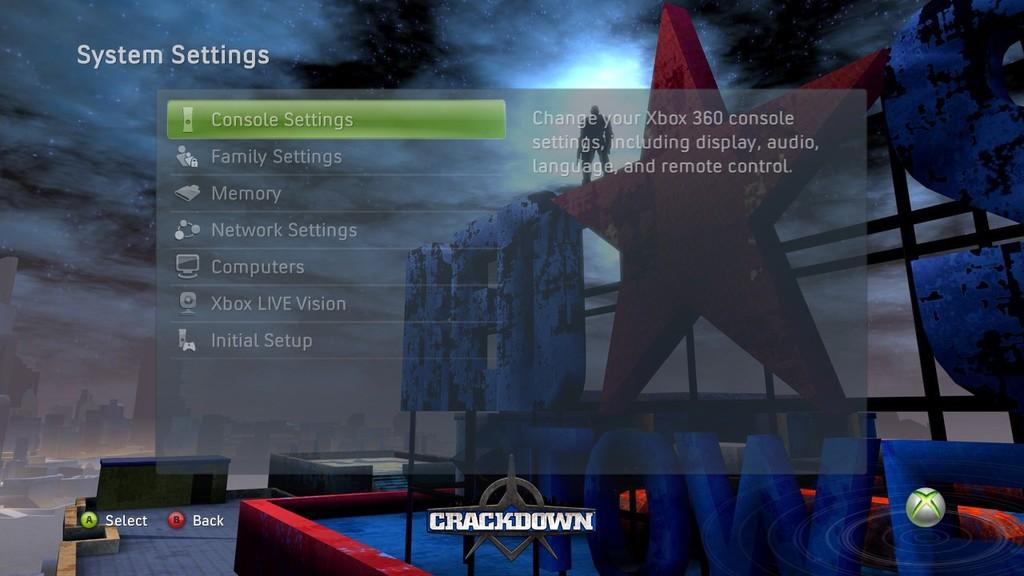What type of image is shown in the screenshot? The image is a screenshot of a game. What can be seen on the screen besides the game? There are multiple options visible in the image. What is the background of the options in the image? There are animated images behind the options. Can you see any gardens in the image? There is no garden present in the image; it is a screenshot of a game with multiple options and animated images. 